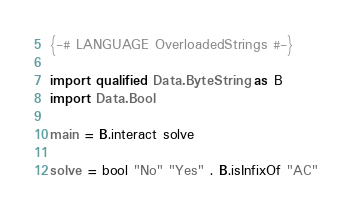Convert code to text. <code><loc_0><loc_0><loc_500><loc_500><_Haskell_>{-# LANGUAGE OverloadedStrings #-} 
 
import qualified Data.ByteString as B
import Data.Bool
 
main = B.interact solve

solve = bool "No" "Yes" . B.isInfixOf "AC"</code> 